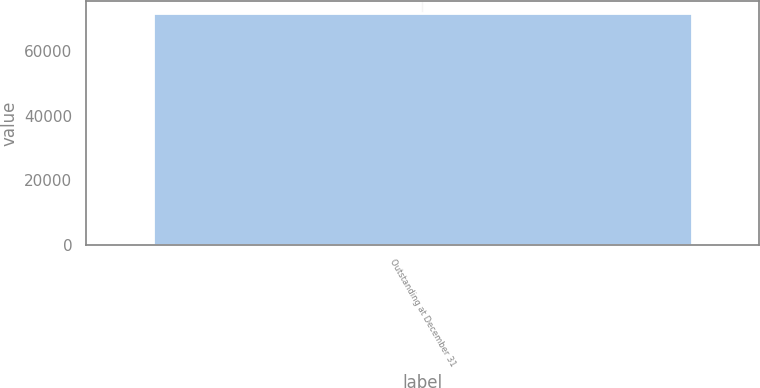<chart> <loc_0><loc_0><loc_500><loc_500><bar_chart><fcel>Outstanding at December 31<nl><fcel>71892<nl></chart> 